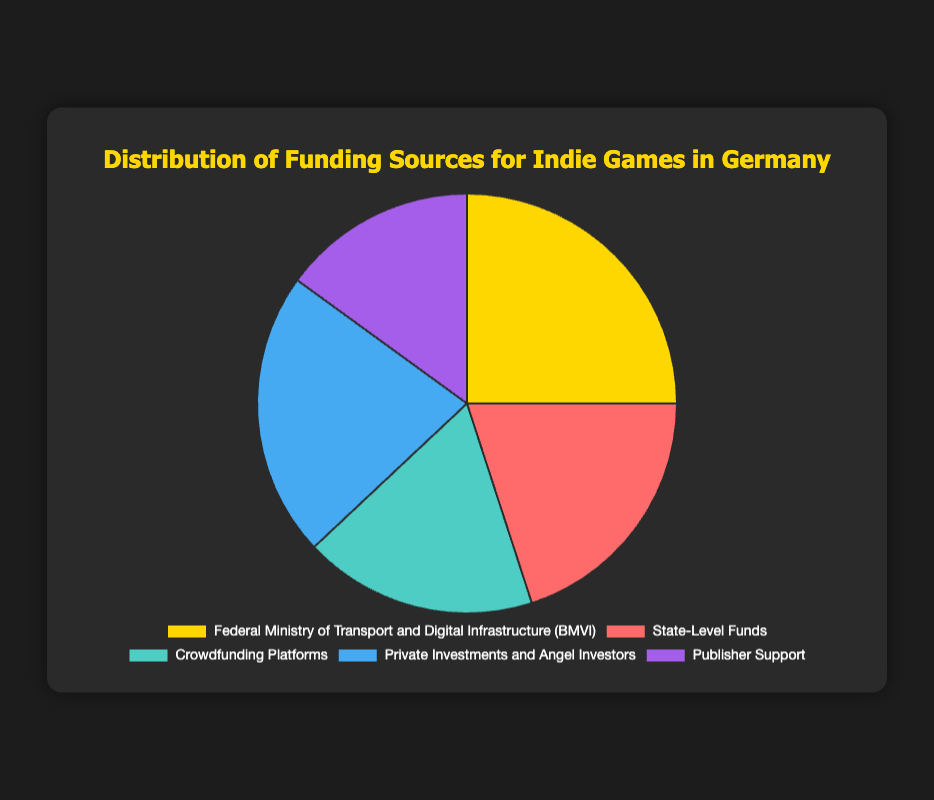What are the top two funding sources for indie games in Germany? The top two funding sources are the ones with the highest percentages. From the chart, "Federal Ministry of Transport and Digital Infrastructure (BMVI)" is at 25% and "Private Investments and Angel Investors" is at 22%.
Answer: Federal Ministry of Transport and Digital Infrastructure (BMVI) and Private Investments and Angel Investors Which funding source contributes the least to indie games in Germany? The funding source with the smallest percentage appears at the bottom of the chart. "Publisher Support" has a percentage of 15%, the lowest among all sources.
Answer: Publisher Support How much more funding does the BMVI provide compared to Crowdfunding Platforms? The BMVI provides 25% and Crowdfunding Platforms provide 18%. The difference is found by subtracting the smaller percentage from the larger one: 25% - 18% = 7%.
Answer: 7% Are State-Level Funds or Publisher Support contributing more to indie game funding in Germany? Comparing their percentages, State-Level Funds contribute 20%, whereas Publisher Support contributes 15%. Since 20% is greater than 15%, State-Level Funds contribute more.
Answer: State-Level Funds What's the combined contribution of Private Investments, Crowdfunding Platforms, and Publisher Support? Sum their percentages: Private Investments (22%) + Crowdfunding Platforms (18%) + Publisher Support (15%) = 55%.
Answer: 55% Which funding source is represented with the color blue in the chart? Identify the color mentioned in the chart for "blue", which is utilized for "Private Investments and Angel Investors".
Answer: Private Investments and Angel Investors What percentage of the funding sources together nearly makes up half of the total funding? Calculate cumulative percentages until you reach near 50%. BMVI (25%) + State-Level Funds (20%) = 45% which is closest to 50%.
Answer: BMVI and State-Level Funds Is there any funding source that contributes exactly one-fifth of the total funding? One-fifth of 100% is 20%. The only source contributing exactly 20% is "State-Level Funds".
Answer: State-Level Funds How does the combined contribution of the BMVI and Publisher Support compare to 40%? Add their percentages: BMVI (25%) + Publisher Support (15%) = 40%. Hence, it equals 40%.
Answer: Equal to 40% What is the average contribution percentage of all the funding sources? Sum all the percentages: 25 + 20 + 18 + 22 + 15 = 100%. There are five funding sources, so divide by 5: 100% / 5 = 20%.
Answer: 20% 